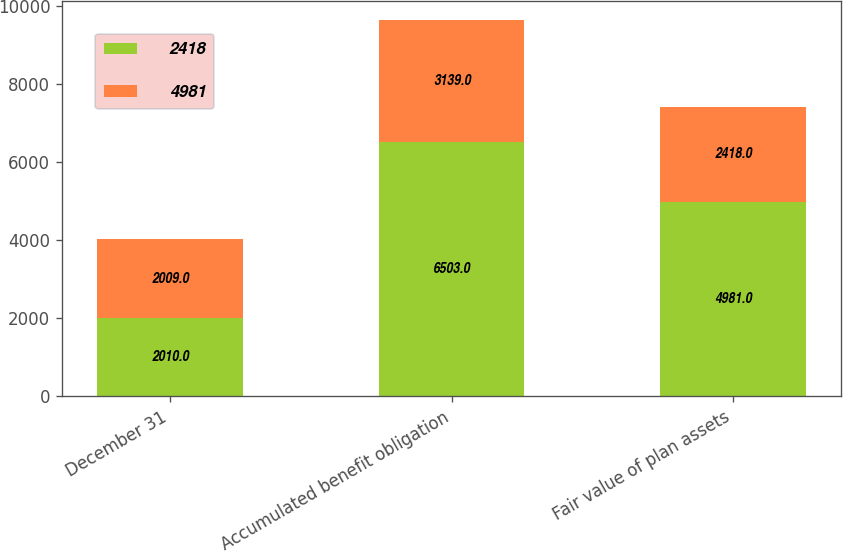<chart> <loc_0><loc_0><loc_500><loc_500><stacked_bar_chart><ecel><fcel>December 31<fcel>Accumulated benefit obligation<fcel>Fair value of plan assets<nl><fcel>2418<fcel>2010<fcel>6503<fcel>4981<nl><fcel>4981<fcel>2009<fcel>3139<fcel>2418<nl></chart> 